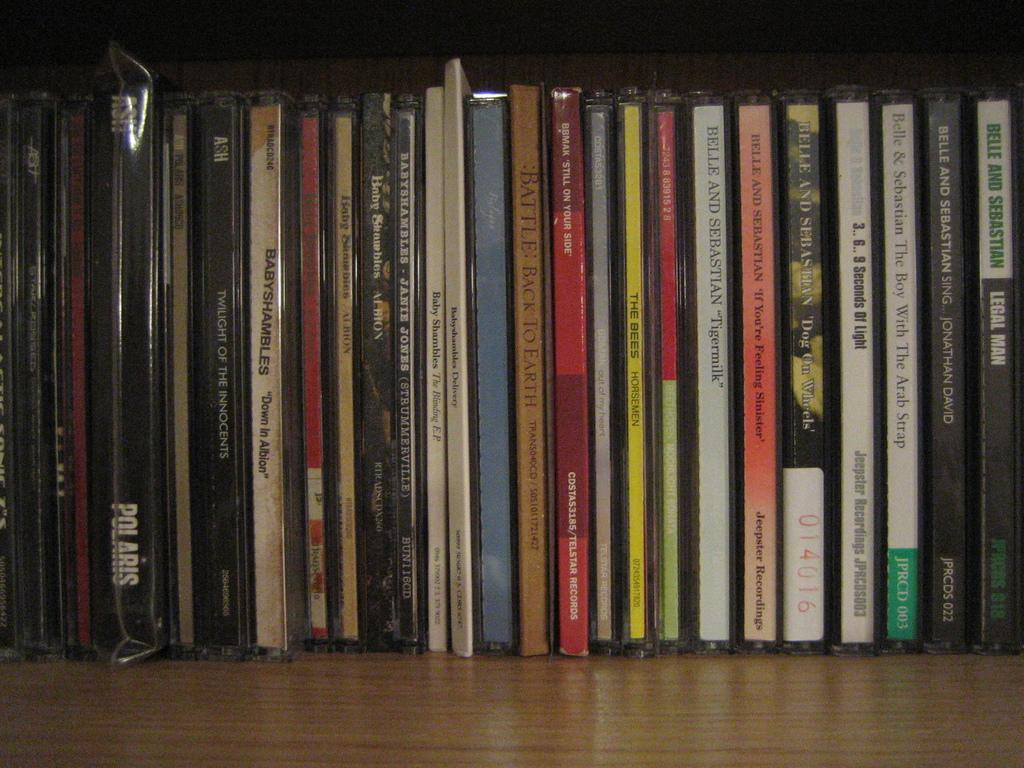<image>
Relay a brief, clear account of the picture shown. A CD by Polaris is mixed in with numerous others. 